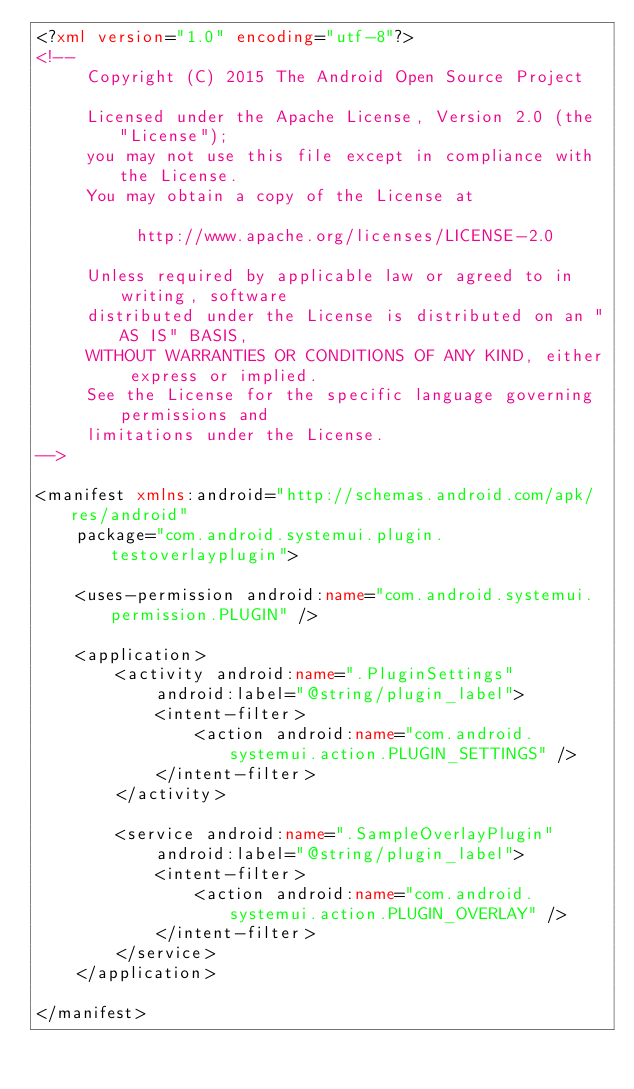Convert code to text. <code><loc_0><loc_0><loc_500><loc_500><_XML_><?xml version="1.0" encoding="utf-8"?>
<!--
     Copyright (C) 2015 The Android Open Source Project

     Licensed under the Apache License, Version 2.0 (the "License");
     you may not use this file except in compliance with the License.
     You may obtain a copy of the License at

          http://www.apache.org/licenses/LICENSE-2.0

     Unless required by applicable law or agreed to in writing, software
     distributed under the License is distributed on an "AS IS" BASIS,
     WITHOUT WARRANTIES OR CONDITIONS OF ANY KIND, either express or implied.
     See the License for the specific language governing permissions and
     limitations under the License.
-->

<manifest xmlns:android="http://schemas.android.com/apk/res/android"
    package="com.android.systemui.plugin.testoverlayplugin">

    <uses-permission android:name="com.android.systemui.permission.PLUGIN" />

    <application>
        <activity android:name=".PluginSettings"
            android:label="@string/plugin_label">
            <intent-filter>
                <action android:name="com.android.systemui.action.PLUGIN_SETTINGS" />
            </intent-filter>
        </activity>

        <service android:name=".SampleOverlayPlugin"
            android:label="@string/plugin_label">
            <intent-filter>
                <action android:name="com.android.systemui.action.PLUGIN_OVERLAY" />
            </intent-filter>
        </service>
    </application>

</manifest>
</code> 